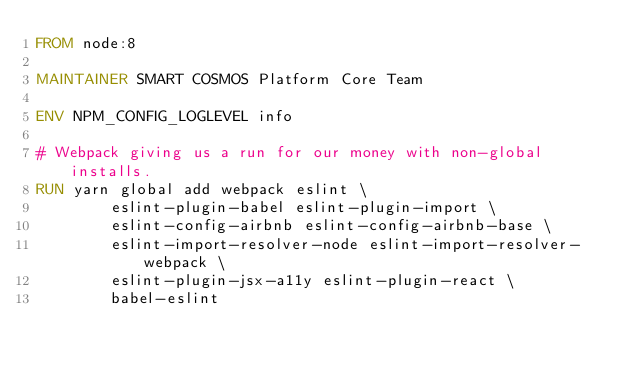<code> <loc_0><loc_0><loc_500><loc_500><_Dockerfile_>FROM node:8

MAINTAINER SMART COSMOS Platform Core Team

ENV NPM_CONFIG_LOGLEVEL info

# Webpack giving us a run for our money with non-global installs.
RUN yarn global add webpack eslint \
        eslint-plugin-babel eslint-plugin-import \
        eslint-config-airbnb eslint-config-airbnb-base \
        eslint-import-resolver-node eslint-import-resolver-webpack \
        eslint-plugin-jsx-a11y eslint-plugin-react \
        babel-eslint
</code> 